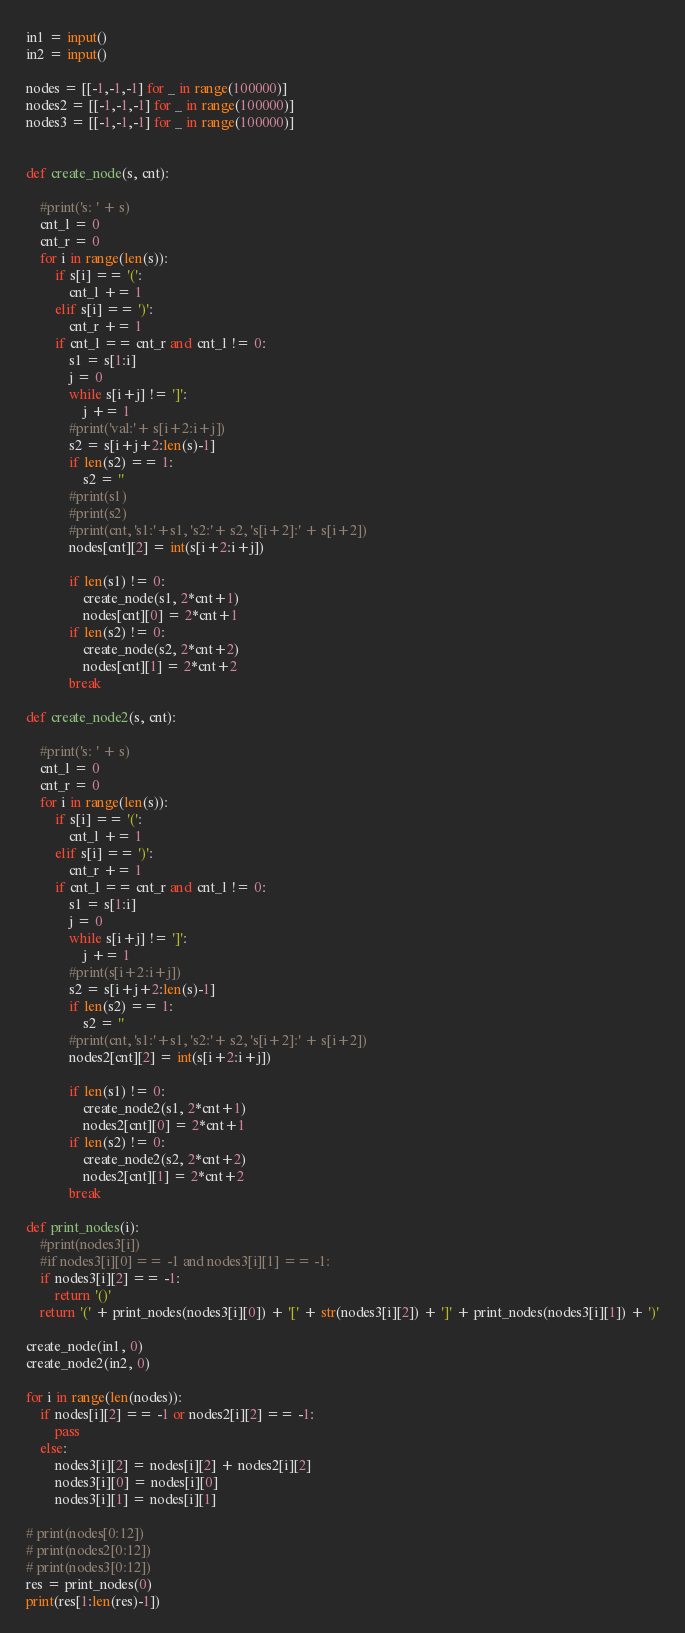Convert code to text. <code><loc_0><loc_0><loc_500><loc_500><_Python_>in1 = input()
in2 = input()

nodes = [[-1,-1,-1] for _ in range(100000)]
nodes2 = [[-1,-1,-1] for _ in range(100000)]
nodes3 = [[-1,-1,-1] for _ in range(100000)]


def create_node(s, cnt):
    
    #print('s: ' + s)
    cnt_l = 0
    cnt_r = 0
    for i in range(len(s)):
        if s[i] == '(':
            cnt_l += 1
        elif s[i] == ')':
            cnt_r += 1
        if cnt_l == cnt_r and cnt_l != 0:
            s1 = s[1:i]
            j = 0
            while s[i+j] != ']':
                j += 1
            #print('val:'+ s[i+2:i+j])
            s2 = s[i+j+2:len(s)-1]
            if len(s2) == 1:
                s2 = ''
            #print(s1)
            #print(s2)
            #print(cnt, 's1:'+s1, 's2:'+ s2, 's[i+2]:' + s[i+2])
            nodes[cnt][2] = int(s[i+2:i+j])
            
            if len(s1) != 0:
                create_node(s1, 2*cnt+1)
                nodes[cnt][0] = 2*cnt+1
            if len(s2) != 0:
                create_node(s2, 2*cnt+2)
                nodes[cnt][1] = 2*cnt+2
            break

def create_node2(s, cnt):
    
    #print('s: ' + s)
    cnt_l = 0
    cnt_r = 0
    for i in range(len(s)):
        if s[i] == '(':
            cnt_l += 1
        elif s[i] == ')':
            cnt_r += 1
        if cnt_l == cnt_r and cnt_l != 0:
            s1 = s[1:i]
            j = 0
            while s[i+j] != ']':
                j += 1
            #print(s[i+2:i+j])
            s2 = s[i+j+2:len(s)-1]
            if len(s2) == 1:
                s2 = ''
            #print(cnt, 's1:'+s1, 's2:'+ s2, 's[i+2]:' + s[i+2])
            nodes2[cnt][2] = int(s[i+2:i+j])
            
            if len(s1) != 0:
                create_node2(s1, 2*cnt+1)
                nodes2[cnt][0] = 2*cnt+1
            if len(s2) != 0:
                create_node2(s2, 2*cnt+2)
                nodes2[cnt][1] = 2*cnt+2
            break

def print_nodes(i):
    #print(nodes3[i])
    #if nodes3[i][0] == -1 and nodes3[i][1] == -1:
    if nodes3[i][2] == -1:
        return '()'
    return '(' + print_nodes(nodes3[i][0]) + '[' + str(nodes3[i][2]) + ']' + print_nodes(nodes3[i][1]) + ')'

create_node(in1, 0)
create_node2(in2, 0)

for i in range(len(nodes)):
    if nodes[i][2] == -1 or nodes2[i][2] == -1:
        pass
    else:
        nodes3[i][2] = nodes[i][2] + nodes2[i][2]
        nodes3[i][0] = nodes[i][0]
        nodes3[i][1] = nodes[i][1]

# print(nodes[0:12])
# print(nodes2[0:12])
# print(nodes3[0:12])
res = print_nodes(0)
print(res[1:len(res)-1])
</code> 